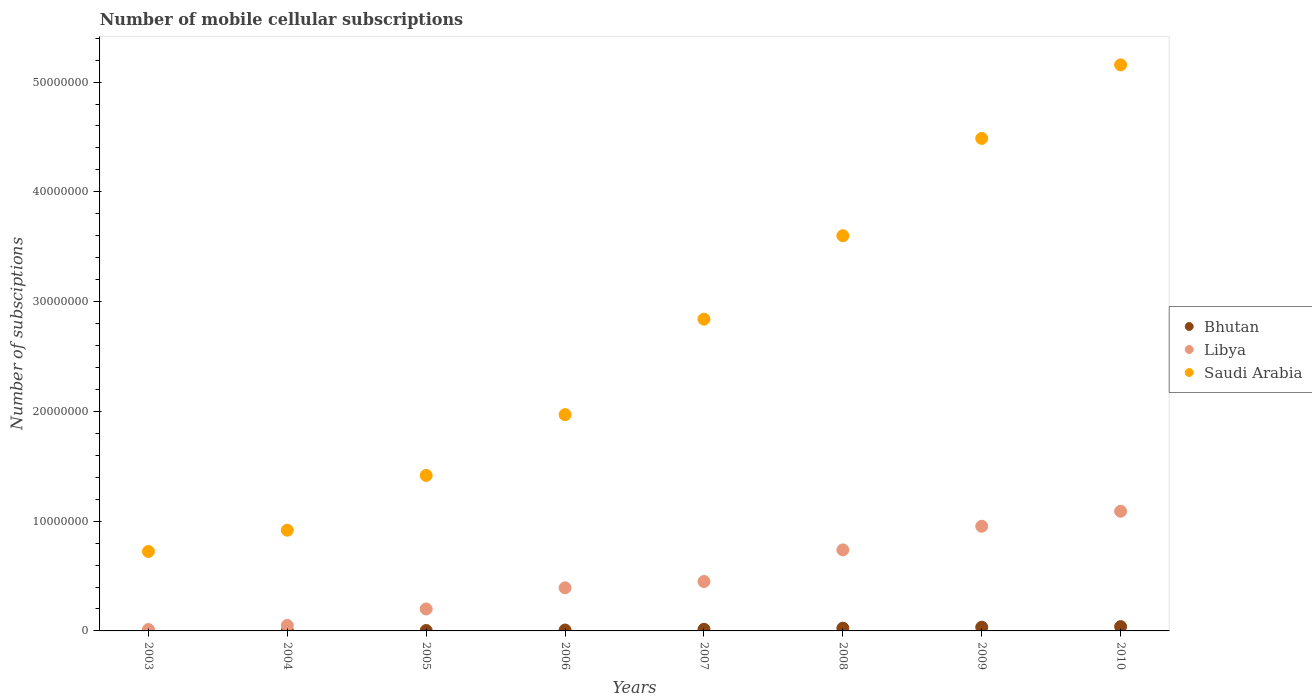Is the number of dotlines equal to the number of legend labels?
Offer a terse response. Yes. What is the number of mobile cellular subscriptions in Bhutan in 2010?
Offer a terse response. 3.94e+05. Across all years, what is the maximum number of mobile cellular subscriptions in Saudi Arabia?
Give a very brief answer. 5.16e+07. Across all years, what is the minimum number of mobile cellular subscriptions in Libya?
Make the answer very short. 1.27e+05. What is the total number of mobile cellular subscriptions in Libya in the graph?
Keep it short and to the point. 3.89e+07. What is the difference between the number of mobile cellular subscriptions in Saudi Arabia in 2007 and that in 2008?
Keep it short and to the point. -7.60e+06. What is the difference between the number of mobile cellular subscriptions in Bhutan in 2005 and the number of mobile cellular subscriptions in Libya in 2009?
Offer a very short reply. -9.50e+06. What is the average number of mobile cellular subscriptions in Bhutan per year?
Your answer should be compact. 1.59e+05. In the year 2004, what is the difference between the number of mobile cellular subscriptions in Saudi Arabia and number of mobile cellular subscriptions in Bhutan?
Give a very brief answer. 9.16e+06. What is the ratio of the number of mobile cellular subscriptions in Bhutan in 2004 to that in 2010?
Offer a very short reply. 0.05. Is the number of mobile cellular subscriptions in Libya in 2005 less than that in 2009?
Give a very brief answer. Yes. Is the difference between the number of mobile cellular subscriptions in Saudi Arabia in 2007 and 2008 greater than the difference between the number of mobile cellular subscriptions in Bhutan in 2007 and 2008?
Your answer should be very brief. No. What is the difference between the highest and the second highest number of mobile cellular subscriptions in Bhutan?
Provide a succinct answer. 5.54e+04. What is the difference between the highest and the lowest number of mobile cellular subscriptions in Bhutan?
Your answer should be very brief. 3.92e+05. Is the sum of the number of mobile cellular subscriptions in Saudi Arabia in 2009 and 2010 greater than the maximum number of mobile cellular subscriptions in Bhutan across all years?
Provide a short and direct response. Yes. Is it the case that in every year, the sum of the number of mobile cellular subscriptions in Libya and number of mobile cellular subscriptions in Saudi Arabia  is greater than the number of mobile cellular subscriptions in Bhutan?
Your response must be concise. Yes. Does the number of mobile cellular subscriptions in Bhutan monotonically increase over the years?
Provide a succinct answer. Yes. Is the number of mobile cellular subscriptions in Libya strictly greater than the number of mobile cellular subscriptions in Saudi Arabia over the years?
Your answer should be very brief. No. Is the number of mobile cellular subscriptions in Libya strictly less than the number of mobile cellular subscriptions in Saudi Arabia over the years?
Your answer should be very brief. Yes. Are the values on the major ticks of Y-axis written in scientific E-notation?
Offer a very short reply. No. Does the graph contain grids?
Your answer should be compact. No. Where does the legend appear in the graph?
Keep it short and to the point. Center right. How many legend labels are there?
Provide a succinct answer. 3. How are the legend labels stacked?
Offer a terse response. Vertical. What is the title of the graph?
Provide a short and direct response. Number of mobile cellular subscriptions. Does "Gabon" appear as one of the legend labels in the graph?
Ensure brevity in your answer.  No. What is the label or title of the Y-axis?
Ensure brevity in your answer.  Number of subsciptions. What is the Number of subsciptions of Bhutan in 2003?
Your response must be concise. 2255. What is the Number of subsciptions of Libya in 2003?
Provide a short and direct response. 1.27e+05. What is the Number of subsciptions of Saudi Arabia in 2003?
Provide a short and direct response. 7.24e+06. What is the Number of subsciptions of Bhutan in 2004?
Give a very brief answer. 1.91e+04. What is the Number of subsciptions in Libya in 2004?
Give a very brief answer. 5.00e+05. What is the Number of subsciptions of Saudi Arabia in 2004?
Offer a very short reply. 9.18e+06. What is the Number of subsciptions in Bhutan in 2005?
Provide a succinct answer. 3.60e+04. What is the Number of subsciptions in Libya in 2005?
Offer a terse response. 2.00e+06. What is the Number of subsciptions in Saudi Arabia in 2005?
Provide a succinct answer. 1.42e+07. What is the Number of subsciptions in Bhutan in 2006?
Your answer should be very brief. 8.21e+04. What is the Number of subsciptions in Libya in 2006?
Provide a short and direct response. 3.93e+06. What is the Number of subsciptions in Saudi Arabia in 2006?
Your answer should be compact. 1.97e+07. What is the Number of subsciptions of Bhutan in 2007?
Offer a very short reply. 1.49e+05. What is the Number of subsciptions in Libya in 2007?
Provide a succinct answer. 4.50e+06. What is the Number of subsciptions in Saudi Arabia in 2007?
Offer a terse response. 2.84e+07. What is the Number of subsciptions of Bhutan in 2008?
Provide a short and direct response. 2.53e+05. What is the Number of subsciptions in Libya in 2008?
Give a very brief answer. 7.38e+06. What is the Number of subsciptions of Saudi Arabia in 2008?
Provide a succinct answer. 3.60e+07. What is the Number of subsciptions in Bhutan in 2009?
Offer a very short reply. 3.39e+05. What is the Number of subsciptions in Libya in 2009?
Give a very brief answer. 9.53e+06. What is the Number of subsciptions in Saudi Arabia in 2009?
Ensure brevity in your answer.  4.49e+07. What is the Number of subsciptions of Bhutan in 2010?
Your answer should be compact. 3.94e+05. What is the Number of subsciptions of Libya in 2010?
Offer a terse response. 1.09e+07. What is the Number of subsciptions in Saudi Arabia in 2010?
Give a very brief answer. 5.16e+07. Across all years, what is the maximum Number of subsciptions of Bhutan?
Ensure brevity in your answer.  3.94e+05. Across all years, what is the maximum Number of subsciptions of Libya?
Give a very brief answer. 1.09e+07. Across all years, what is the maximum Number of subsciptions of Saudi Arabia?
Provide a short and direct response. 5.16e+07. Across all years, what is the minimum Number of subsciptions of Bhutan?
Make the answer very short. 2255. Across all years, what is the minimum Number of subsciptions in Libya?
Your answer should be compact. 1.27e+05. Across all years, what is the minimum Number of subsciptions in Saudi Arabia?
Give a very brief answer. 7.24e+06. What is the total Number of subsciptions of Bhutan in the graph?
Ensure brevity in your answer.  1.28e+06. What is the total Number of subsciptions in Libya in the graph?
Your response must be concise. 3.89e+07. What is the total Number of subsciptions of Saudi Arabia in the graph?
Your answer should be compact. 2.11e+08. What is the difference between the Number of subsciptions in Bhutan in 2003 and that in 2004?
Your answer should be compact. -1.69e+04. What is the difference between the Number of subsciptions of Libya in 2003 and that in 2004?
Provide a succinct answer. -3.73e+05. What is the difference between the Number of subsciptions of Saudi Arabia in 2003 and that in 2004?
Make the answer very short. -1.94e+06. What is the difference between the Number of subsciptions of Bhutan in 2003 and that in 2005?
Ensure brevity in your answer.  -3.37e+04. What is the difference between the Number of subsciptions of Libya in 2003 and that in 2005?
Offer a very short reply. -1.87e+06. What is the difference between the Number of subsciptions in Saudi Arabia in 2003 and that in 2005?
Keep it short and to the point. -6.93e+06. What is the difference between the Number of subsciptions of Bhutan in 2003 and that in 2006?
Keep it short and to the point. -7.98e+04. What is the difference between the Number of subsciptions of Libya in 2003 and that in 2006?
Your answer should be compact. -3.80e+06. What is the difference between the Number of subsciptions of Saudi Arabia in 2003 and that in 2006?
Your response must be concise. -1.25e+07. What is the difference between the Number of subsciptions in Bhutan in 2003 and that in 2007?
Give a very brief answer. -1.47e+05. What is the difference between the Number of subsciptions in Libya in 2003 and that in 2007?
Offer a terse response. -4.37e+06. What is the difference between the Number of subsciptions of Saudi Arabia in 2003 and that in 2007?
Provide a short and direct response. -2.12e+07. What is the difference between the Number of subsciptions of Bhutan in 2003 and that in 2008?
Keep it short and to the point. -2.51e+05. What is the difference between the Number of subsciptions in Libya in 2003 and that in 2008?
Your response must be concise. -7.25e+06. What is the difference between the Number of subsciptions in Saudi Arabia in 2003 and that in 2008?
Keep it short and to the point. -2.88e+07. What is the difference between the Number of subsciptions in Bhutan in 2003 and that in 2009?
Your response must be concise. -3.37e+05. What is the difference between the Number of subsciptions in Libya in 2003 and that in 2009?
Offer a very short reply. -9.41e+06. What is the difference between the Number of subsciptions in Saudi Arabia in 2003 and that in 2009?
Your response must be concise. -3.76e+07. What is the difference between the Number of subsciptions of Bhutan in 2003 and that in 2010?
Offer a terse response. -3.92e+05. What is the difference between the Number of subsciptions of Libya in 2003 and that in 2010?
Offer a very short reply. -1.08e+07. What is the difference between the Number of subsciptions of Saudi Arabia in 2003 and that in 2010?
Your answer should be very brief. -4.43e+07. What is the difference between the Number of subsciptions of Bhutan in 2004 and that in 2005?
Give a very brief answer. -1.69e+04. What is the difference between the Number of subsciptions in Libya in 2004 and that in 2005?
Make the answer very short. -1.50e+06. What is the difference between the Number of subsciptions in Saudi Arabia in 2004 and that in 2005?
Offer a terse response. -4.99e+06. What is the difference between the Number of subsciptions in Bhutan in 2004 and that in 2006?
Your response must be concise. -6.29e+04. What is the difference between the Number of subsciptions of Libya in 2004 and that in 2006?
Provide a short and direct response. -3.43e+06. What is the difference between the Number of subsciptions in Saudi Arabia in 2004 and that in 2006?
Your answer should be compact. -1.05e+07. What is the difference between the Number of subsciptions in Bhutan in 2004 and that in 2007?
Offer a very short reply. -1.30e+05. What is the difference between the Number of subsciptions of Saudi Arabia in 2004 and that in 2007?
Keep it short and to the point. -1.92e+07. What is the difference between the Number of subsciptions in Bhutan in 2004 and that in 2008?
Ensure brevity in your answer.  -2.34e+05. What is the difference between the Number of subsciptions of Libya in 2004 and that in 2008?
Offer a very short reply. -6.88e+06. What is the difference between the Number of subsciptions of Saudi Arabia in 2004 and that in 2008?
Provide a succinct answer. -2.68e+07. What is the difference between the Number of subsciptions of Bhutan in 2004 and that in 2009?
Give a very brief answer. -3.20e+05. What is the difference between the Number of subsciptions in Libya in 2004 and that in 2009?
Offer a terse response. -9.03e+06. What is the difference between the Number of subsciptions of Saudi Arabia in 2004 and that in 2009?
Provide a succinct answer. -3.57e+07. What is the difference between the Number of subsciptions of Bhutan in 2004 and that in 2010?
Offer a very short reply. -3.75e+05. What is the difference between the Number of subsciptions in Libya in 2004 and that in 2010?
Keep it short and to the point. -1.04e+07. What is the difference between the Number of subsciptions of Saudi Arabia in 2004 and that in 2010?
Ensure brevity in your answer.  -4.24e+07. What is the difference between the Number of subsciptions in Bhutan in 2005 and that in 2006?
Provide a short and direct response. -4.61e+04. What is the difference between the Number of subsciptions of Libya in 2005 and that in 2006?
Offer a terse response. -1.93e+06. What is the difference between the Number of subsciptions in Saudi Arabia in 2005 and that in 2006?
Your answer should be very brief. -5.54e+06. What is the difference between the Number of subsciptions of Bhutan in 2005 and that in 2007?
Your response must be concise. -1.13e+05. What is the difference between the Number of subsciptions of Libya in 2005 and that in 2007?
Give a very brief answer. -2.50e+06. What is the difference between the Number of subsciptions of Saudi Arabia in 2005 and that in 2007?
Offer a terse response. -1.42e+07. What is the difference between the Number of subsciptions in Bhutan in 2005 and that in 2008?
Your answer should be very brief. -2.17e+05. What is the difference between the Number of subsciptions in Libya in 2005 and that in 2008?
Ensure brevity in your answer.  -5.38e+06. What is the difference between the Number of subsciptions in Saudi Arabia in 2005 and that in 2008?
Your answer should be compact. -2.18e+07. What is the difference between the Number of subsciptions of Bhutan in 2005 and that in 2009?
Keep it short and to the point. -3.03e+05. What is the difference between the Number of subsciptions in Libya in 2005 and that in 2009?
Your answer should be very brief. -7.53e+06. What is the difference between the Number of subsciptions in Saudi Arabia in 2005 and that in 2009?
Ensure brevity in your answer.  -3.07e+07. What is the difference between the Number of subsciptions in Bhutan in 2005 and that in 2010?
Your response must be concise. -3.58e+05. What is the difference between the Number of subsciptions of Libya in 2005 and that in 2010?
Offer a terse response. -8.90e+06. What is the difference between the Number of subsciptions in Saudi Arabia in 2005 and that in 2010?
Your answer should be very brief. -3.74e+07. What is the difference between the Number of subsciptions in Bhutan in 2006 and that in 2007?
Your answer should be very brief. -6.74e+04. What is the difference between the Number of subsciptions of Libya in 2006 and that in 2007?
Ensure brevity in your answer.  -5.72e+05. What is the difference between the Number of subsciptions in Saudi Arabia in 2006 and that in 2007?
Your answer should be compact. -8.70e+06. What is the difference between the Number of subsciptions in Bhutan in 2006 and that in 2008?
Your answer should be very brief. -1.71e+05. What is the difference between the Number of subsciptions in Libya in 2006 and that in 2008?
Make the answer very short. -3.45e+06. What is the difference between the Number of subsciptions of Saudi Arabia in 2006 and that in 2008?
Keep it short and to the point. -1.63e+07. What is the difference between the Number of subsciptions of Bhutan in 2006 and that in 2009?
Make the answer very short. -2.57e+05. What is the difference between the Number of subsciptions in Libya in 2006 and that in 2009?
Keep it short and to the point. -5.61e+06. What is the difference between the Number of subsciptions in Saudi Arabia in 2006 and that in 2009?
Ensure brevity in your answer.  -2.52e+07. What is the difference between the Number of subsciptions in Bhutan in 2006 and that in 2010?
Your answer should be compact. -3.12e+05. What is the difference between the Number of subsciptions in Libya in 2006 and that in 2010?
Offer a very short reply. -6.97e+06. What is the difference between the Number of subsciptions in Saudi Arabia in 2006 and that in 2010?
Give a very brief answer. -3.19e+07. What is the difference between the Number of subsciptions of Bhutan in 2007 and that in 2008?
Provide a succinct answer. -1.04e+05. What is the difference between the Number of subsciptions in Libya in 2007 and that in 2008?
Your answer should be compact. -2.88e+06. What is the difference between the Number of subsciptions in Saudi Arabia in 2007 and that in 2008?
Give a very brief answer. -7.60e+06. What is the difference between the Number of subsciptions of Bhutan in 2007 and that in 2009?
Your answer should be very brief. -1.89e+05. What is the difference between the Number of subsciptions of Libya in 2007 and that in 2009?
Provide a short and direct response. -5.03e+06. What is the difference between the Number of subsciptions in Saudi Arabia in 2007 and that in 2009?
Provide a succinct answer. -1.65e+07. What is the difference between the Number of subsciptions of Bhutan in 2007 and that in 2010?
Give a very brief answer. -2.45e+05. What is the difference between the Number of subsciptions of Libya in 2007 and that in 2010?
Give a very brief answer. -6.40e+06. What is the difference between the Number of subsciptions in Saudi Arabia in 2007 and that in 2010?
Give a very brief answer. -2.32e+07. What is the difference between the Number of subsciptions in Bhutan in 2008 and that in 2009?
Give a very brief answer. -8.55e+04. What is the difference between the Number of subsciptions of Libya in 2008 and that in 2009?
Provide a succinct answer. -2.15e+06. What is the difference between the Number of subsciptions of Saudi Arabia in 2008 and that in 2009?
Make the answer very short. -8.86e+06. What is the difference between the Number of subsciptions of Bhutan in 2008 and that in 2010?
Your response must be concise. -1.41e+05. What is the difference between the Number of subsciptions of Libya in 2008 and that in 2010?
Provide a short and direct response. -3.52e+06. What is the difference between the Number of subsciptions of Saudi Arabia in 2008 and that in 2010?
Offer a terse response. -1.56e+07. What is the difference between the Number of subsciptions of Bhutan in 2009 and that in 2010?
Your answer should be very brief. -5.54e+04. What is the difference between the Number of subsciptions of Libya in 2009 and that in 2010?
Keep it short and to the point. -1.37e+06. What is the difference between the Number of subsciptions of Saudi Arabia in 2009 and that in 2010?
Offer a terse response. -6.70e+06. What is the difference between the Number of subsciptions of Bhutan in 2003 and the Number of subsciptions of Libya in 2004?
Your answer should be compact. -4.98e+05. What is the difference between the Number of subsciptions in Bhutan in 2003 and the Number of subsciptions in Saudi Arabia in 2004?
Keep it short and to the point. -9.17e+06. What is the difference between the Number of subsciptions in Libya in 2003 and the Number of subsciptions in Saudi Arabia in 2004?
Keep it short and to the point. -9.05e+06. What is the difference between the Number of subsciptions of Bhutan in 2003 and the Number of subsciptions of Libya in 2005?
Your answer should be very brief. -2.00e+06. What is the difference between the Number of subsciptions in Bhutan in 2003 and the Number of subsciptions in Saudi Arabia in 2005?
Your response must be concise. -1.42e+07. What is the difference between the Number of subsciptions in Libya in 2003 and the Number of subsciptions in Saudi Arabia in 2005?
Ensure brevity in your answer.  -1.40e+07. What is the difference between the Number of subsciptions of Bhutan in 2003 and the Number of subsciptions of Libya in 2006?
Your response must be concise. -3.93e+06. What is the difference between the Number of subsciptions of Bhutan in 2003 and the Number of subsciptions of Saudi Arabia in 2006?
Keep it short and to the point. -1.97e+07. What is the difference between the Number of subsciptions in Libya in 2003 and the Number of subsciptions in Saudi Arabia in 2006?
Provide a short and direct response. -1.96e+07. What is the difference between the Number of subsciptions in Bhutan in 2003 and the Number of subsciptions in Libya in 2007?
Offer a very short reply. -4.50e+06. What is the difference between the Number of subsciptions in Bhutan in 2003 and the Number of subsciptions in Saudi Arabia in 2007?
Your response must be concise. -2.84e+07. What is the difference between the Number of subsciptions of Libya in 2003 and the Number of subsciptions of Saudi Arabia in 2007?
Provide a succinct answer. -2.83e+07. What is the difference between the Number of subsciptions in Bhutan in 2003 and the Number of subsciptions in Libya in 2008?
Provide a succinct answer. -7.38e+06. What is the difference between the Number of subsciptions of Bhutan in 2003 and the Number of subsciptions of Saudi Arabia in 2008?
Your response must be concise. -3.60e+07. What is the difference between the Number of subsciptions in Libya in 2003 and the Number of subsciptions in Saudi Arabia in 2008?
Give a very brief answer. -3.59e+07. What is the difference between the Number of subsciptions in Bhutan in 2003 and the Number of subsciptions in Libya in 2009?
Your response must be concise. -9.53e+06. What is the difference between the Number of subsciptions in Bhutan in 2003 and the Number of subsciptions in Saudi Arabia in 2009?
Provide a short and direct response. -4.49e+07. What is the difference between the Number of subsciptions in Libya in 2003 and the Number of subsciptions in Saudi Arabia in 2009?
Your answer should be very brief. -4.47e+07. What is the difference between the Number of subsciptions of Bhutan in 2003 and the Number of subsciptions of Libya in 2010?
Your response must be concise. -1.09e+07. What is the difference between the Number of subsciptions of Bhutan in 2003 and the Number of subsciptions of Saudi Arabia in 2010?
Your response must be concise. -5.16e+07. What is the difference between the Number of subsciptions of Libya in 2003 and the Number of subsciptions of Saudi Arabia in 2010?
Keep it short and to the point. -5.14e+07. What is the difference between the Number of subsciptions in Bhutan in 2004 and the Number of subsciptions in Libya in 2005?
Your answer should be very brief. -1.98e+06. What is the difference between the Number of subsciptions in Bhutan in 2004 and the Number of subsciptions in Saudi Arabia in 2005?
Give a very brief answer. -1.41e+07. What is the difference between the Number of subsciptions of Libya in 2004 and the Number of subsciptions of Saudi Arabia in 2005?
Your answer should be compact. -1.37e+07. What is the difference between the Number of subsciptions of Bhutan in 2004 and the Number of subsciptions of Libya in 2006?
Give a very brief answer. -3.91e+06. What is the difference between the Number of subsciptions of Bhutan in 2004 and the Number of subsciptions of Saudi Arabia in 2006?
Your answer should be compact. -1.97e+07. What is the difference between the Number of subsciptions of Libya in 2004 and the Number of subsciptions of Saudi Arabia in 2006?
Offer a very short reply. -1.92e+07. What is the difference between the Number of subsciptions of Bhutan in 2004 and the Number of subsciptions of Libya in 2007?
Provide a short and direct response. -4.48e+06. What is the difference between the Number of subsciptions in Bhutan in 2004 and the Number of subsciptions in Saudi Arabia in 2007?
Ensure brevity in your answer.  -2.84e+07. What is the difference between the Number of subsciptions of Libya in 2004 and the Number of subsciptions of Saudi Arabia in 2007?
Offer a terse response. -2.79e+07. What is the difference between the Number of subsciptions of Bhutan in 2004 and the Number of subsciptions of Libya in 2008?
Your answer should be very brief. -7.36e+06. What is the difference between the Number of subsciptions in Bhutan in 2004 and the Number of subsciptions in Saudi Arabia in 2008?
Make the answer very short. -3.60e+07. What is the difference between the Number of subsciptions of Libya in 2004 and the Number of subsciptions of Saudi Arabia in 2008?
Keep it short and to the point. -3.55e+07. What is the difference between the Number of subsciptions in Bhutan in 2004 and the Number of subsciptions in Libya in 2009?
Offer a very short reply. -9.51e+06. What is the difference between the Number of subsciptions of Bhutan in 2004 and the Number of subsciptions of Saudi Arabia in 2009?
Ensure brevity in your answer.  -4.48e+07. What is the difference between the Number of subsciptions in Libya in 2004 and the Number of subsciptions in Saudi Arabia in 2009?
Provide a succinct answer. -4.44e+07. What is the difference between the Number of subsciptions of Bhutan in 2004 and the Number of subsciptions of Libya in 2010?
Offer a very short reply. -1.09e+07. What is the difference between the Number of subsciptions of Bhutan in 2004 and the Number of subsciptions of Saudi Arabia in 2010?
Offer a very short reply. -5.15e+07. What is the difference between the Number of subsciptions of Libya in 2004 and the Number of subsciptions of Saudi Arabia in 2010?
Your answer should be compact. -5.11e+07. What is the difference between the Number of subsciptions in Bhutan in 2005 and the Number of subsciptions in Libya in 2006?
Your answer should be compact. -3.89e+06. What is the difference between the Number of subsciptions in Bhutan in 2005 and the Number of subsciptions in Saudi Arabia in 2006?
Provide a short and direct response. -1.97e+07. What is the difference between the Number of subsciptions in Libya in 2005 and the Number of subsciptions in Saudi Arabia in 2006?
Ensure brevity in your answer.  -1.77e+07. What is the difference between the Number of subsciptions of Bhutan in 2005 and the Number of subsciptions of Libya in 2007?
Give a very brief answer. -4.46e+06. What is the difference between the Number of subsciptions of Bhutan in 2005 and the Number of subsciptions of Saudi Arabia in 2007?
Make the answer very short. -2.84e+07. What is the difference between the Number of subsciptions of Libya in 2005 and the Number of subsciptions of Saudi Arabia in 2007?
Make the answer very short. -2.64e+07. What is the difference between the Number of subsciptions of Bhutan in 2005 and the Number of subsciptions of Libya in 2008?
Offer a very short reply. -7.34e+06. What is the difference between the Number of subsciptions of Bhutan in 2005 and the Number of subsciptions of Saudi Arabia in 2008?
Your answer should be very brief. -3.60e+07. What is the difference between the Number of subsciptions of Libya in 2005 and the Number of subsciptions of Saudi Arabia in 2008?
Your answer should be compact. -3.40e+07. What is the difference between the Number of subsciptions of Bhutan in 2005 and the Number of subsciptions of Libya in 2009?
Provide a short and direct response. -9.50e+06. What is the difference between the Number of subsciptions in Bhutan in 2005 and the Number of subsciptions in Saudi Arabia in 2009?
Offer a terse response. -4.48e+07. What is the difference between the Number of subsciptions in Libya in 2005 and the Number of subsciptions in Saudi Arabia in 2009?
Offer a very short reply. -4.29e+07. What is the difference between the Number of subsciptions in Bhutan in 2005 and the Number of subsciptions in Libya in 2010?
Give a very brief answer. -1.09e+07. What is the difference between the Number of subsciptions in Bhutan in 2005 and the Number of subsciptions in Saudi Arabia in 2010?
Your response must be concise. -5.15e+07. What is the difference between the Number of subsciptions in Libya in 2005 and the Number of subsciptions in Saudi Arabia in 2010?
Give a very brief answer. -4.96e+07. What is the difference between the Number of subsciptions in Bhutan in 2006 and the Number of subsciptions in Libya in 2007?
Provide a succinct answer. -4.42e+06. What is the difference between the Number of subsciptions of Bhutan in 2006 and the Number of subsciptions of Saudi Arabia in 2007?
Offer a terse response. -2.83e+07. What is the difference between the Number of subsciptions of Libya in 2006 and the Number of subsciptions of Saudi Arabia in 2007?
Your answer should be compact. -2.45e+07. What is the difference between the Number of subsciptions in Bhutan in 2006 and the Number of subsciptions in Libya in 2008?
Ensure brevity in your answer.  -7.30e+06. What is the difference between the Number of subsciptions in Bhutan in 2006 and the Number of subsciptions in Saudi Arabia in 2008?
Keep it short and to the point. -3.59e+07. What is the difference between the Number of subsciptions of Libya in 2006 and the Number of subsciptions of Saudi Arabia in 2008?
Keep it short and to the point. -3.21e+07. What is the difference between the Number of subsciptions of Bhutan in 2006 and the Number of subsciptions of Libya in 2009?
Give a very brief answer. -9.45e+06. What is the difference between the Number of subsciptions of Bhutan in 2006 and the Number of subsciptions of Saudi Arabia in 2009?
Your response must be concise. -4.48e+07. What is the difference between the Number of subsciptions in Libya in 2006 and the Number of subsciptions in Saudi Arabia in 2009?
Make the answer very short. -4.09e+07. What is the difference between the Number of subsciptions in Bhutan in 2006 and the Number of subsciptions in Libya in 2010?
Your answer should be very brief. -1.08e+07. What is the difference between the Number of subsciptions in Bhutan in 2006 and the Number of subsciptions in Saudi Arabia in 2010?
Your answer should be very brief. -5.15e+07. What is the difference between the Number of subsciptions in Libya in 2006 and the Number of subsciptions in Saudi Arabia in 2010?
Offer a terse response. -4.76e+07. What is the difference between the Number of subsciptions in Bhutan in 2007 and the Number of subsciptions in Libya in 2008?
Provide a short and direct response. -7.23e+06. What is the difference between the Number of subsciptions in Bhutan in 2007 and the Number of subsciptions in Saudi Arabia in 2008?
Provide a succinct answer. -3.59e+07. What is the difference between the Number of subsciptions of Libya in 2007 and the Number of subsciptions of Saudi Arabia in 2008?
Ensure brevity in your answer.  -3.15e+07. What is the difference between the Number of subsciptions in Bhutan in 2007 and the Number of subsciptions in Libya in 2009?
Ensure brevity in your answer.  -9.38e+06. What is the difference between the Number of subsciptions in Bhutan in 2007 and the Number of subsciptions in Saudi Arabia in 2009?
Give a very brief answer. -4.47e+07. What is the difference between the Number of subsciptions of Libya in 2007 and the Number of subsciptions of Saudi Arabia in 2009?
Provide a short and direct response. -4.04e+07. What is the difference between the Number of subsciptions of Bhutan in 2007 and the Number of subsciptions of Libya in 2010?
Keep it short and to the point. -1.08e+07. What is the difference between the Number of subsciptions in Bhutan in 2007 and the Number of subsciptions in Saudi Arabia in 2010?
Ensure brevity in your answer.  -5.14e+07. What is the difference between the Number of subsciptions in Libya in 2007 and the Number of subsciptions in Saudi Arabia in 2010?
Provide a succinct answer. -4.71e+07. What is the difference between the Number of subsciptions in Bhutan in 2008 and the Number of subsciptions in Libya in 2009?
Provide a succinct answer. -9.28e+06. What is the difference between the Number of subsciptions in Bhutan in 2008 and the Number of subsciptions in Saudi Arabia in 2009?
Provide a succinct answer. -4.46e+07. What is the difference between the Number of subsciptions in Libya in 2008 and the Number of subsciptions in Saudi Arabia in 2009?
Provide a short and direct response. -3.75e+07. What is the difference between the Number of subsciptions in Bhutan in 2008 and the Number of subsciptions in Libya in 2010?
Provide a succinct answer. -1.06e+07. What is the difference between the Number of subsciptions in Bhutan in 2008 and the Number of subsciptions in Saudi Arabia in 2010?
Offer a very short reply. -5.13e+07. What is the difference between the Number of subsciptions in Libya in 2008 and the Number of subsciptions in Saudi Arabia in 2010?
Make the answer very short. -4.42e+07. What is the difference between the Number of subsciptions of Bhutan in 2009 and the Number of subsciptions of Libya in 2010?
Offer a terse response. -1.06e+07. What is the difference between the Number of subsciptions of Bhutan in 2009 and the Number of subsciptions of Saudi Arabia in 2010?
Ensure brevity in your answer.  -5.12e+07. What is the difference between the Number of subsciptions in Libya in 2009 and the Number of subsciptions in Saudi Arabia in 2010?
Provide a short and direct response. -4.20e+07. What is the average Number of subsciptions of Bhutan per year?
Keep it short and to the point. 1.59e+05. What is the average Number of subsciptions of Libya per year?
Give a very brief answer. 4.86e+06. What is the average Number of subsciptions of Saudi Arabia per year?
Offer a very short reply. 2.64e+07. In the year 2003, what is the difference between the Number of subsciptions in Bhutan and Number of subsciptions in Libya?
Your response must be concise. -1.25e+05. In the year 2003, what is the difference between the Number of subsciptions in Bhutan and Number of subsciptions in Saudi Arabia?
Your answer should be compact. -7.24e+06. In the year 2003, what is the difference between the Number of subsciptions of Libya and Number of subsciptions of Saudi Arabia?
Keep it short and to the point. -7.11e+06. In the year 2004, what is the difference between the Number of subsciptions in Bhutan and Number of subsciptions in Libya?
Make the answer very short. -4.81e+05. In the year 2004, what is the difference between the Number of subsciptions of Bhutan and Number of subsciptions of Saudi Arabia?
Your response must be concise. -9.16e+06. In the year 2004, what is the difference between the Number of subsciptions of Libya and Number of subsciptions of Saudi Arabia?
Offer a terse response. -8.68e+06. In the year 2005, what is the difference between the Number of subsciptions in Bhutan and Number of subsciptions in Libya?
Provide a succinct answer. -1.96e+06. In the year 2005, what is the difference between the Number of subsciptions in Bhutan and Number of subsciptions in Saudi Arabia?
Your response must be concise. -1.41e+07. In the year 2005, what is the difference between the Number of subsciptions in Libya and Number of subsciptions in Saudi Arabia?
Offer a very short reply. -1.22e+07. In the year 2006, what is the difference between the Number of subsciptions of Bhutan and Number of subsciptions of Libya?
Give a very brief answer. -3.85e+06. In the year 2006, what is the difference between the Number of subsciptions in Bhutan and Number of subsciptions in Saudi Arabia?
Offer a terse response. -1.96e+07. In the year 2006, what is the difference between the Number of subsciptions of Libya and Number of subsciptions of Saudi Arabia?
Offer a terse response. -1.58e+07. In the year 2007, what is the difference between the Number of subsciptions in Bhutan and Number of subsciptions in Libya?
Your answer should be compact. -4.35e+06. In the year 2007, what is the difference between the Number of subsciptions of Bhutan and Number of subsciptions of Saudi Arabia?
Make the answer very short. -2.83e+07. In the year 2007, what is the difference between the Number of subsciptions of Libya and Number of subsciptions of Saudi Arabia?
Offer a very short reply. -2.39e+07. In the year 2008, what is the difference between the Number of subsciptions of Bhutan and Number of subsciptions of Libya?
Offer a very short reply. -7.13e+06. In the year 2008, what is the difference between the Number of subsciptions of Bhutan and Number of subsciptions of Saudi Arabia?
Give a very brief answer. -3.57e+07. In the year 2008, what is the difference between the Number of subsciptions of Libya and Number of subsciptions of Saudi Arabia?
Keep it short and to the point. -2.86e+07. In the year 2009, what is the difference between the Number of subsciptions in Bhutan and Number of subsciptions in Libya?
Offer a very short reply. -9.20e+06. In the year 2009, what is the difference between the Number of subsciptions of Bhutan and Number of subsciptions of Saudi Arabia?
Offer a terse response. -4.45e+07. In the year 2009, what is the difference between the Number of subsciptions in Libya and Number of subsciptions in Saudi Arabia?
Provide a short and direct response. -3.53e+07. In the year 2010, what is the difference between the Number of subsciptions of Bhutan and Number of subsciptions of Libya?
Provide a succinct answer. -1.05e+07. In the year 2010, what is the difference between the Number of subsciptions of Bhutan and Number of subsciptions of Saudi Arabia?
Provide a short and direct response. -5.12e+07. In the year 2010, what is the difference between the Number of subsciptions of Libya and Number of subsciptions of Saudi Arabia?
Offer a very short reply. -4.07e+07. What is the ratio of the Number of subsciptions of Bhutan in 2003 to that in 2004?
Offer a very short reply. 0.12. What is the ratio of the Number of subsciptions of Libya in 2003 to that in 2004?
Your answer should be compact. 0.25. What is the ratio of the Number of subsciptions of Saudi Arabia in 2003 to that in 2004?
Ensure brevity in your answer.  0.79. What is the ratio of the Number of subsciptions of Bhutan in 2003 to that in 2005?
Your answer should be compact. 0.06. What is the ratio of the Number of subsciptions of Libya in 2003 to that in 2005?
Keep it short and to the point. 0.06. What is the ratio of the Number of subsciptions of Saudi Arabia in 2003 to that in 2005?
Make the answer very short. 0.51. What is the ratio of the Number of subsciptions in Bhutan in 2003 to that in 2006?
Keep it short and to the point. 0.03. What is the ratio of the Number of subsciptions in Libya in 2003 to that in 2006?
Offer a very short reply. 0.03. What is the ratio of the Number of subsciptions in Saudi Arabia in 2003 to that in 2006?
Offer a very short reply. 0.37. What is the ratio of the Number of subsciptions of Bhutan in 2003 to that in 2007?
Provide a short and direct response. 0.02. What is the ratio of the Number of subsciptions in Libya in 2003 to that in 2007?
Your answer should be very brief. 0.03. What is the ratio of the Number of subsciptions of Saudi Arabia in 2003 to that in 2007?
Provide a short and direct response. 0.25. What is the ratio of the Number of subsciptions in Bhutan in 2003 to that in 2008?
Your answer should be very brief. 0.01. What is the ratio of the Number of subsciptions in Libya in 2003 to that in 2008?
Offer a very short reply. 0.02. What is the ratio of the Number of subsciptions in Saudi Arabia in 2003 to that in 2008?
Offer a terse response. 0.2. What is the ratio of the Number of subsciptions in Bhutan in 2003 to that in 2009?
Your answer should be very brief. 0.01. What is the ratio of the Number of subsciptions of Libya in 2003 to that in 2009?
Keep it short and to the point. 0.01. What is the ratio of the Number of subsciptions of Saudi Arabia in 2003 to that in 2009?
Ensure brevity in your answer.  0.16. What is the ratio of the Number of subsciptions of Bhutan in 2003 to that in 2010?
Your answer should be very brief. 0.01. What is the ratio of the Number of subsciptions in Libya in 2003 to that in 2010?
Provide a short and direct response. 0.01. What is the ratio of the Number of subsciptions in Saudi Arabia in 2003 to that in 2010?
Offer a terse response. 0.14. What is the ratio of the Number of subsciptions in Bhutan in 2004 to that in 2005?
Your response must be concise. 0.53. What is the ratio of the Number of subsciptions in Saudi Arabia in 2004 to that in 2005?
Ensure brevity in your answer.  0.65. What is the ratio of the Number of subsciptions in Bhutan in 2004 to that in 2006?
Provide a succinct answer. 0.23. What is the ratio of the Number of subsciptions in Libya in 2004 to that in 2006?
Your response must be concise. 0.13. What is the ratio of the Number of subsciptions of Saudi Arabia in 2004 to that in 2006?
Give a very brief answer. 0.47. What is the ratio of the Number of subsciptions in Bhutan in 2004 to that in 2007?
Your answer should be compact. 0.13. What is the ratio of the Number of subsciptions in Saudi Arabia in 2004 to that in 2007?
Offer a very short reply. 0.32. What is the ratio of the Number of subsciptions in Bhutan in 2004 to that in 2008?
Make the answer very short. 0.08. What is the ratio of the Number of subsciptions of Libya in 2004 to that in 2008?
Your answer should be very brief. 0.07. What is the ratio of the Number of subsciptions in Saudi Arabia in 2004 to that in 2008?
Offer a very short reply. 0.25. What is the ratio of the Number of subsciptions of Bhutan in 2004 to that in 2009?
Make the answer very short. 0.06. What is the ratio of the Number of subsciptions in Libya in 2004 to that in 2009?
Provide a short and direct response. 0.05. What is the ratio of the Number of subsciptions of Saudi Arabia in 2004 to that in 2009?
Offer a terse response. 0.2. What is the ratio of the Number of subsciptions in Bhutan in 2004 to that in 2010?
Your answer should be very brief. 0.05. What is the ratio of the Number of subsciptions in Libya in 2004 to that in 2010?
Your answer should be compact. 0.05. What is the ratio of the Number of subsciptions in Saudi Arabia in 2004 to that in 2010?
Offer a very short reply. 0.18. What is the ratio of the Number of subsciptions in Bhutan in 2005 to that in 2006?
Make the answer very short. 0.44. What is the ratio of the Number of subsciptions in Libya in 2005 to that in 2006?
Provide a short and direct response. 0.51. What is the ratio of the Number of subsciptions in Saudi Arabia in 2005 to that in 2006?
Provide a short and direct response. 0.72. What is the ratio of the Number of subsciptions of Bhutan in 2005 to that in 2007?
Your answer should be compact. 0.24. What is the ratio of the Number of subsciptions of Libya in 2005 to that in 2007?
Provide a succinct answer. 0.44. What is the ratio of the Number of subsciptions in Saudi Arabia in 2005 to that in 2007?
Your answer should be very brief. 0.5. What is the ratio of the Number of subsciptions of Bhutan in 2005 to that in 2008?
Provide a succinct answer. 0.14. What is the ratio of the Number of subsciptions in Libya in 2005 to that in 2008?
Make the answer very short. 0.27. What is the ratio of the Number of subsciptions of Saudi Arabia in 2005 to that in 2008?
Your answer should be compact. 0.39. What is the ratio of the Number of subsciptions of Bhutan in 2005 to that in 2009?
Provide a short and direct response. 0.11. What is the ratio of the Number of subsciptions of Libya in 2005 to that in 2009?
Provide a short and direct response. 0.21. What is the ratio of the Number of subsciptions in Saudi Arabia in 2005 to that in 2009?
Offer a terse response. 0.32. What is the ratio of the Number of subsciptions of Bhutan in 2005 to that in 2010?
Ensure brevity in your answer.  0.09. What is the ratio of the Number of subsciptions in Libya in 2005 to that in 2010?
Make the answer very short. 0.18. What is the ratio of the Number of subsciptions in Saudi Arabia in 2005 to that in 2010?
Give a very brief answer. 0.27. What is the ratio of the Number of subsciptions of Bhutan in 2006 to that in 2007?
Provide a short and direct response. 0.55. What is the ratio of the Number of subsciptions in Libya in 2006 to that in 2007?
Offer a very short reply. 0.87. What is the ratio of the Number of subsciptions of Saudi Arabia in 2006 to that in 2007?
Your answer should be compact. 0.69. What is the ratio of the Number of subsciptions in Bhutan in 2006 to that in 2008?
Offer a very short reply. 0.32. What is the ratio of the Number of subsciptions of Libya in 2006 to that in 2008?
Provide a succinct answer. 0.53. What is the ratio of the Number of subsciptions of Saudi Arabia in 2006 to that in 2008?
Provide a succinct answer. 0.55. What is the ratio of the Number of subsciptions of Bhutan in 2006 to that in 2009?
Offer a terse response. 0.24. What is the ratio of the Number of subsciptions in Libya in 2006 to that in 2009?
Make the answer very short. 0.41. What is the ratio of the Number of subsciptions of Saudi Arabia in 2006 to that in 2009?
Ensure brevity in your answer.  0.44. What is the ratio of the Number of subsciptions of Bhutan in 2006 to that in 2010?
Your answer should be very brief. 0.21. What is the ratio of the Number of subsciptions of Libya in 2006 to that in 2010?
Your answer should be compact. 0.36. What is the ratio of the Number of subsciptions of Saudi Arabia in 2006 to that in 2010?
Provide a short and direct response. 0.38. What is the ratio of the Number of subsciptions of Bhutan in 2007 to that in 2008?
Ensure brevity in your answer.  0.59. What is the ratio of the Number of subsciptions of Libya in 2007 to that in 2008?
Provide a succinct answer. 0.61. What is the ratio of the Number of subsciptions in Saudi Arabia in 2007 to that in 2008?
Offer a terse response. 0.79. What is the ratio of the Number of subsciptions in Bhutan in 2007 to that in 2009?
Keep it short and to the point. 0.44. What is the ratio of the Number of subsciptions of Libya in 2007 to that in 2009?
Offer a very short reply. 0.47. What is the ratio of the Number of subsciptions in Saudi Arabia in 2007 to that in 2009?
Your answer should be compact. 0.63. What is the ratio of the Number of subsciptions in Bhutan in 2007 to that in 2010?
Your answer should be compact. 0.38. What is the ratio of the Number of subsciptions in Libya in 2007 to that in 2010?
Your response must be concise. 0.41. What is the ratio of the Number of subsciptions in Saudi Arabia in 2007 to that in 2010?
Give a very brief answer. 0.55. What is the ratio of the Number of subsciptions of Bhutan in 2008 to that in 2009?
Your answer should be very brief. 0.75. What is the ratio of the Number of subsciptions of Libya in 2008 to that in 2009?
Ensure brevity in your answer.  0.77. What is the ratio of the Number of subsciptions in Saudi Arabia in 2008 to that in 2009?
Your answer should be compact. 0.8. What is the ratio of the Number of subsciptions in Bhutan in 2008 to that in 2010?
Offer a terse response. 0.64. What is the ratio of the Number of subsciptions in Libya in 2008 to that in 2010?
Make the answer very short. 0.68. What is the ratio of the Number of subsciptions in Saudi Arabia in 2008 to that in 2010?
Provide a succinct answer. 0.7. What is the ratio of the Number of subsciptions in Bhutan in 2009 to that in 2010?
Provide a short and direct response. 0.86. What is the ratio of the Number of subsciptions of Libya in 2009 to that in 2010?
Your response must be concise. 0.87. What is the ratio of the Number of subsciptions of Saudi Arabia in 2009 to that in 2010?
Your answer should be compact. 0.87. What is the difference between the highest and the second highest Number of subsciptions in Bhutan?
Your answer should be very brief. 5.54e+04. What is the difference between the highest and the second highest Number of subsciptions of Libya?
Your answer should be compact. 1.37e+06. What is the difference between the highest and the second highest Number of subsciptions of Saudi Arabia?
Give a very brief answer. 6.70e+06. What is the difference between the highest and the lowest Number of subsciptions in Bhutan?
Offer a very short reply. 3.92e+05. What is the difference between the highest and the lowest Number of subsciptions in Libya?
Your answer should be compact. 1.08e+07. What is the difference between the highest and the lowest Number of subsciptions of Saudi Arabia?
Your answer should be very brief. 4.43e+07. 